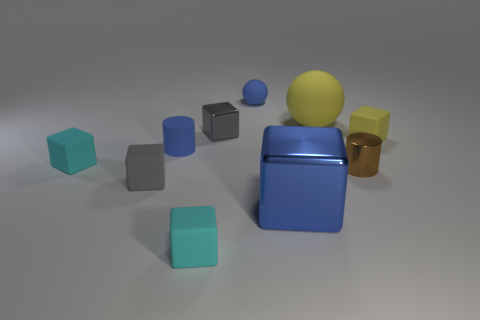Can you describe the surface on which the objects are resting? The objects are resting on what seems to be a matte, slightly reflective surface. It's uniform in color and texture, which creates a neutral platform that doesn't detract from the various objects positioned upon it. 